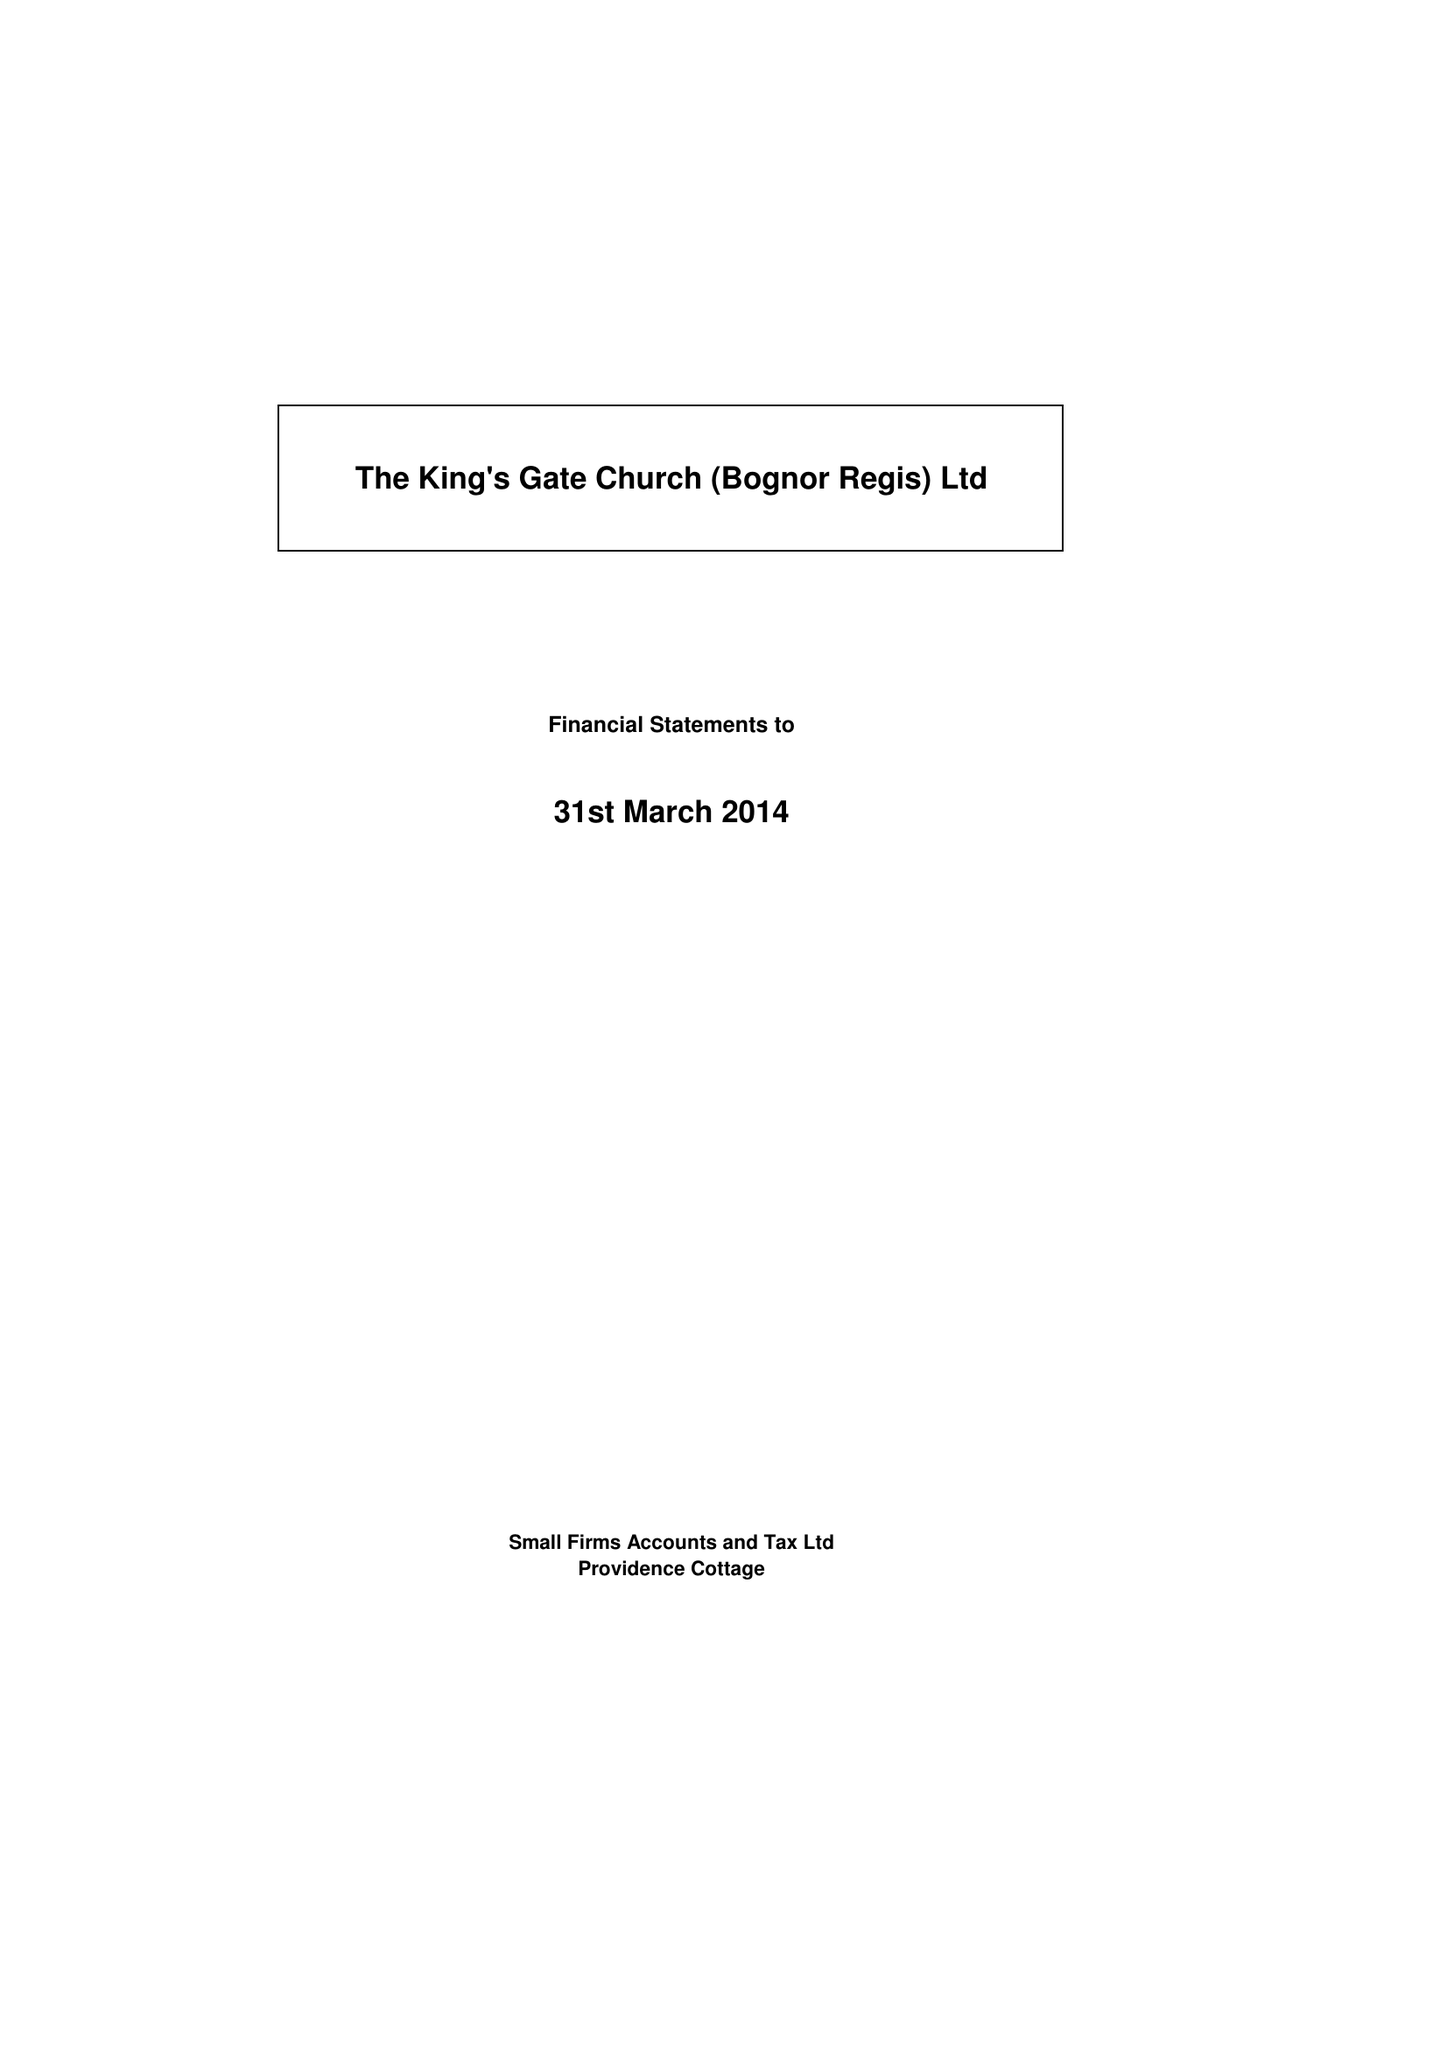What is the value for the spending_annually_in_british_pounds?
Answer the question using a single word or phrase. 62954.00 